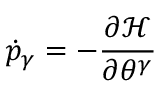<formula> <loc_0><loc_0><loc_500><loc_500>\dot { p } _ { \gamma } = - \frac { \partial \mathcal { H } } { \partial \theta ^ { \gamma } }</formula> 